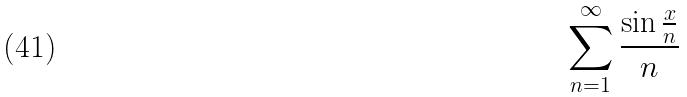<formula> <loc_0><loc_0><loc_500><loc_500>\sum _ { n = 1 } ^ { \infty } \frac { \sin \frac { x } { n } } { n }</formula> 